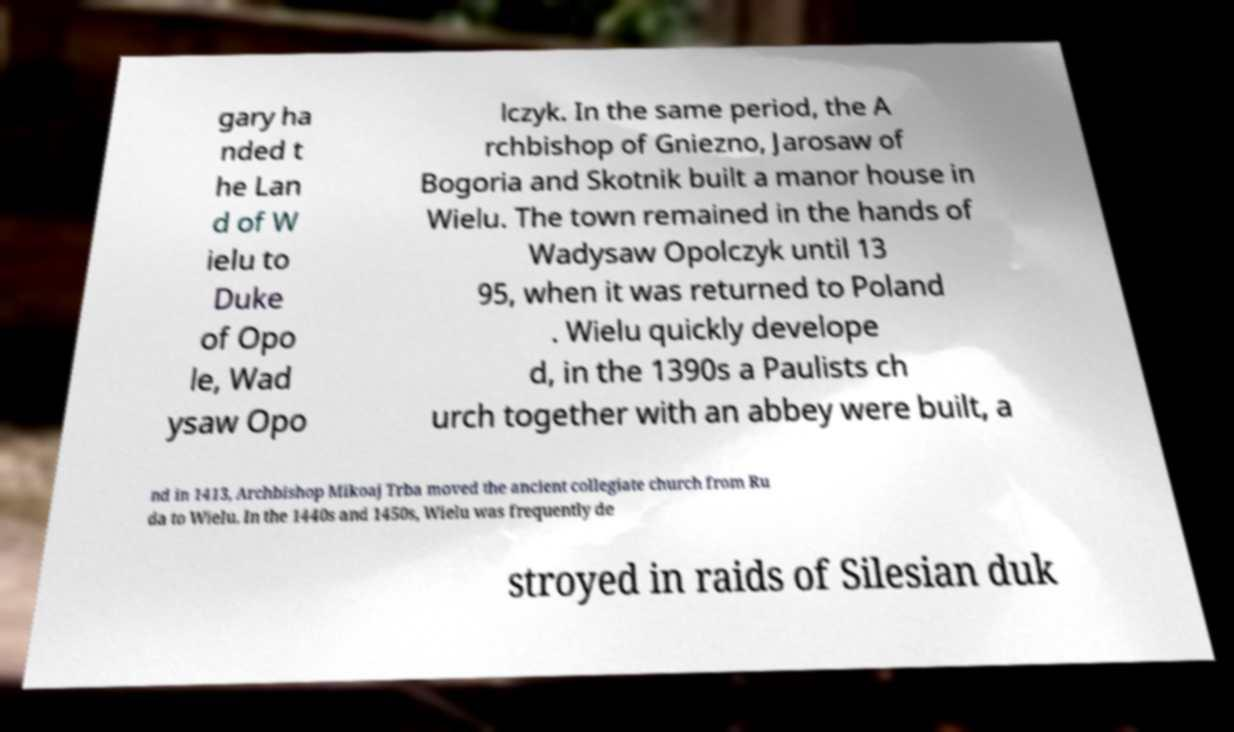Can you read and provide the text displayed in the image?This photo seems to have some interesting text. Can you extract and type it out for me? gary ha nded t he Lan d of W ielu to Duke of Opo le, Wad ysaw Opo lczyk. In the same period, the A rchbishop of Gniezno, Jarosaw of Bogoria and Skotnik built a manor house in Wielu. The town remained in the hands of Wadysaw Opolczyk until 13 95, when it was returned to Poland . Wielu quickly develope d, in the 1390s a Paulists ch urch together with an abbey were built, a nd in 1413, Archbishop Mikoaj Trba moved the ancient collegiate church from Ru da to Wielu. In the 1440s and 1450s, Wielu was frequently de stroyed in raids of Silesian duk 